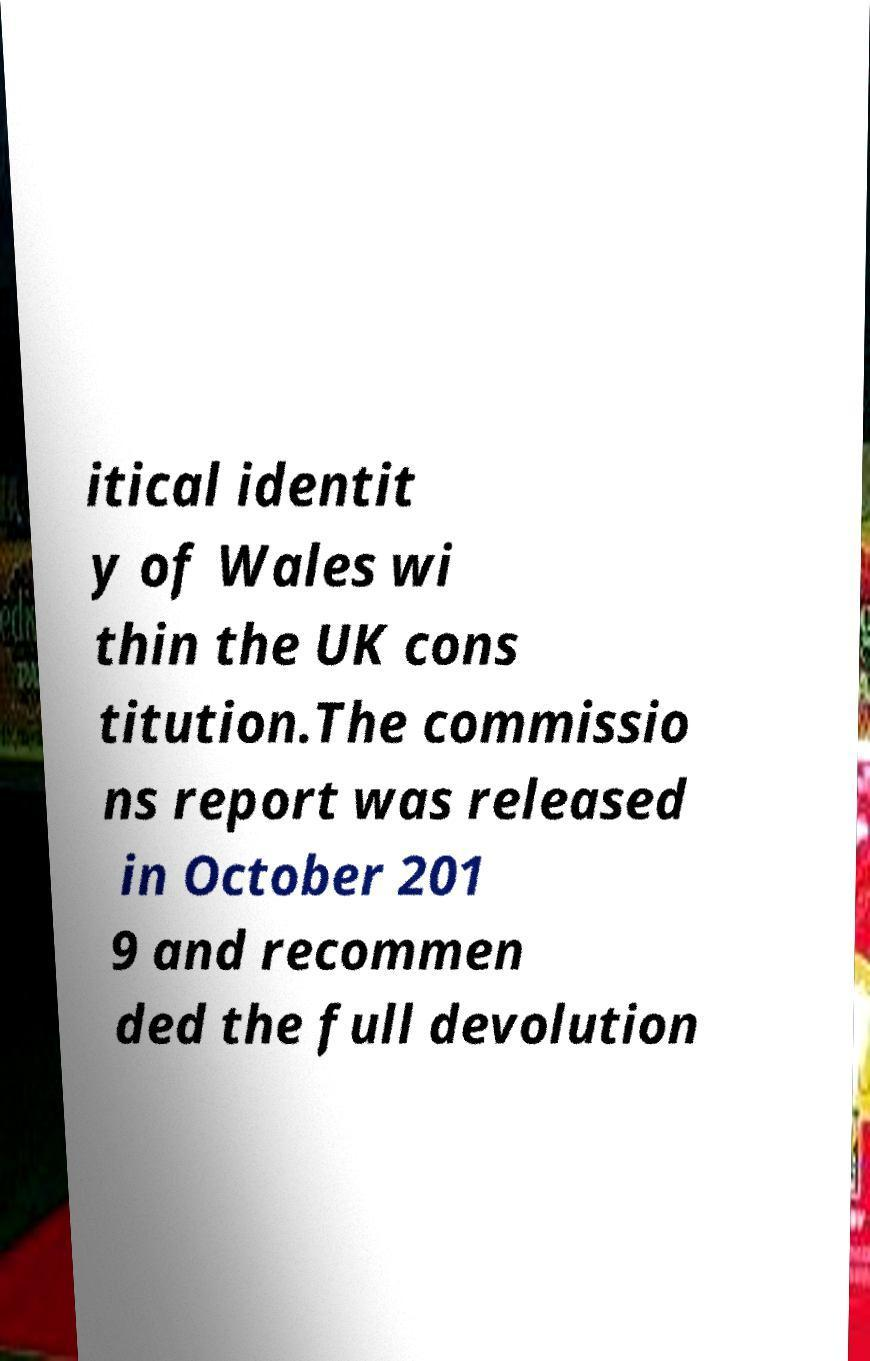Can you read and provide the text displayed in the image?This photo seems to have some interesting text. Can you extract and type it out for me? itical identit y of Wales wi thin the UK cons titution.The commissio ns report was released in October 201 9 and recommen ded the full devolution 